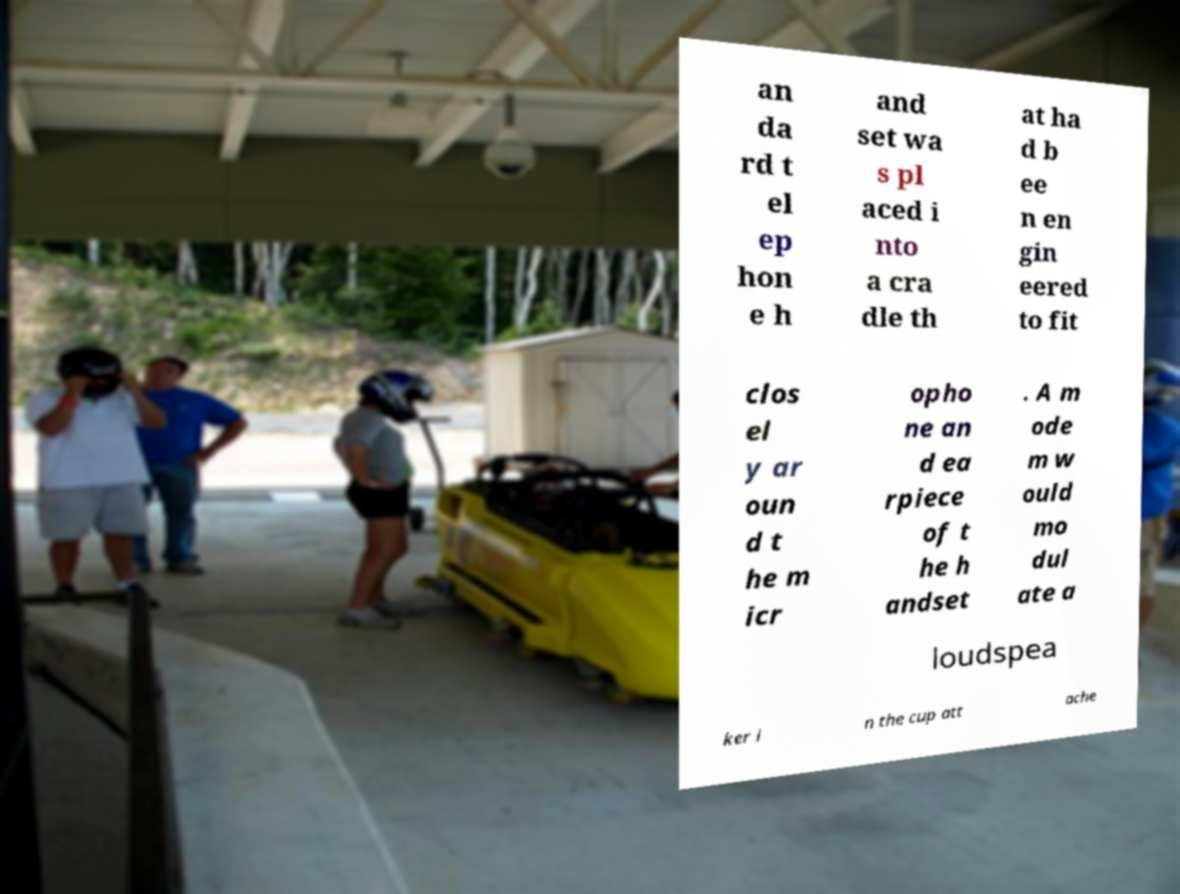Please identify and transcribe the text found in this image. an da rd t el ep hon e h and set wa s pl aced i nto a cra dle th at ha d b ee n en gin eered to fit clos el y ar oun d t he m icr opho ne an d ea rpiece of t he h andset . A m ode m w ould mo dul ate a loudspea ker i n the cup att ache 